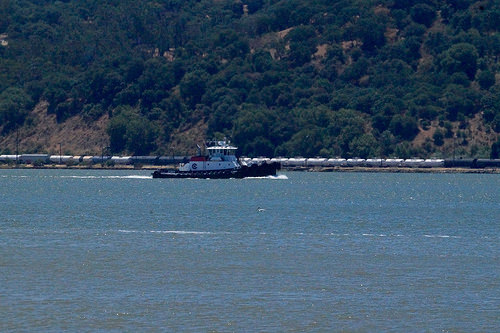<image>
Can you confirm if the tree is on the boat? No. The tree is not positioned on the boat. They may be near each other, but the tree is not supported by or resting on top of the boat. 